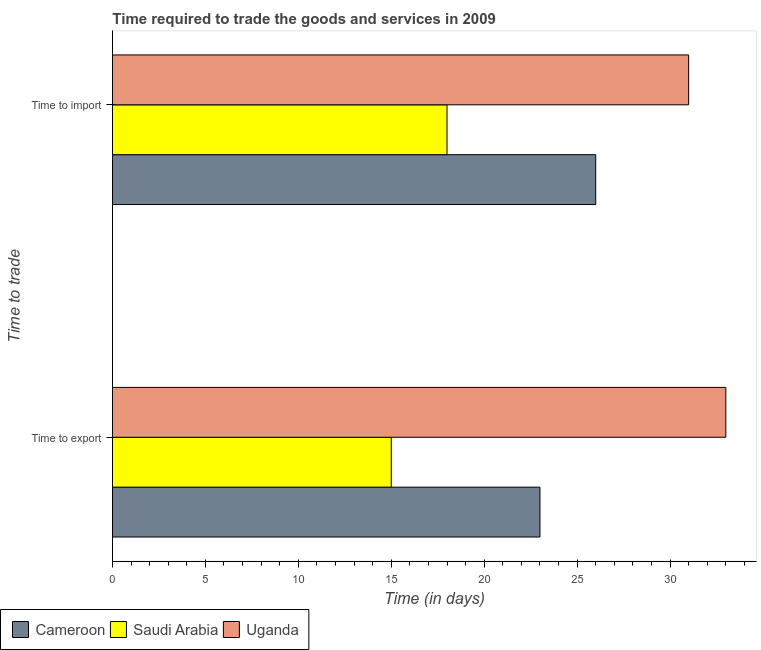Are the number of bars per tick equal to the number of legend labels?
Offer a very short reply. Yes. How many bars are there on the 1st tick from the bottom?
Keep it short and to the point. 3. What is the label of the 1st group of bars from the top?
Offer a terse response. Time to import. What is the time to import in Cameroon?
Offer a very short reply. 26. Across all countries, what is the maximum time to export?
Provide a short and direct response. 33. Across all countries, what is the minimum time to import?
Offer a very short reply. 18. In which country was the time to export maximum?
Provide a short and direct response. Uganda. In which country was the time to export minimum?
Your answer should be compact. Saudi Arabia. What is the total time to import in the graph?
Your response must be concise. 75. What is the difference between the time to export in Saudi Arabia and that in Uganda?
Ensure brevity in your answer.  -18. What is the difference between the time to import in Cameroon and the time to export in Saudi Arabia?
Your answer should be very brief. 11. What is the difference between the time to import and time to export in Uganda?
Ensure brevity in your answer.  -2. In how many countries, is the time to export greater than 20 days?
Ensure brevity in your answer.  2. What is the ratio of the time to import in Saudi Arabia to that in Cameroon?
Your response must be concise. 0.69. Is the time to export in Saudi Arabia less than that in Uganda?
Your response must be concise. Yes. What does the 2nd bar from the top in Time to export represents?
Make the answer very short. Saudi Arabia. What does the 1st bar from the bottom in Time to export represents?
Provide a short and direct response. Cameroon. How many bars are there?
Provide a short and direct response. 6. Are the values on the major ticks of X-axis written in scientific E-notation?
Your answer should be very brief. No. Does the graph contain any zero values?
Provide a short and direct response. No. Does the graph contain grids?
Your answer should be very brief. No. How many legend labels are there?
Your answer should be very brief. 3. How are the legend labels stacked?
Make the answer very short. Horizontal. What is the title of the graph?
Offer a very short reply. Time required to trade the goods and services in 2009. What is the label or title of the X-axis?
Your answer should be compact. Time (in days). What is the label or title of the Y-axis?
Your answer should be very brief. Time to trade. What is the Time (in days) in Cameroon in Time to export?
Your answer should be compact. 23. What is the Time (in days) in Saudi Arabia in Time to export?
Keep it short and to the point. 15. What is the Time (in days) of Uganda in Time to export?
Provide a succinct answer. 33. What is the Time (in days) in Saudi Arabia in Time to import?
Offer a terse response. 18. What is the Time (in days) of Uganda in Time to import?
Give a very brief answer. 31. Across all Time to trade, what is the maximum Time (in days) of Uganda?
Your answer should be very brief. 33. Across all Time to trade, what is the minimum Time (in days) of Uganda?
Keep it short and to the point. 31. What is the total Time (in days) in Uganda in the graph?
Give a very brief answer. 64. What is the difference between the Time (in days) of Cameroon in Time to export and that in Time to import?
Offer a terse response. -3. What is the difference between the Time (in days) in Saudi Arabia in Time to export and that in Time to import?
Your response must be concise. -3. What is the difference between the Time (in days) of Uganda in Time to export and that in Time to import?
Provide a short and direct response. 2. What is the difference between the Time (in days) in Cameroon in Time to export and the Time (in days) in Saudi Arabia in Time to import?
Offer a very short reply. 5. What is the average Time (in days) in Cameroon per Time to trade?
Make the answer very short. 24.5. What is the difference between the Time (in days) of Cameroon and Time (in days) of Uganda in Time to export?
Your answer should be very brief. -10. What is the difference between the Time (in days) of Saudi Arabia and Time (in days) of Uganda in Time to export?
Make the answer very short. -18. What is the difference between the Time (in days) of Cameroon and Time (in days) of Uganda in Time to import?
Your response must be concise. -5. What is the difference between the Time (in days) in Saudi Arabia and Time (in days) in Uganda in Time to import?
Keep it short and to the point. -13. What is the ratio of the Time (in days) of Cameroon in Time to export to that in Time to import?
Keep it short and to the point. 0.88. What is the ratio of the Time (in days) in Saudi Arabia in Time to export to that in Time to import?
Ensure brevity in your answer.  0.83. What is the ratio of the Time (in days) in Uganda in Time to export to that in Time to import?
Keep it short and to the point. 1.06. What is the difference between the highest and the lowest Time (in days) in Cameroon?
Provide a succinct answer. 3. What is the difference between the highest and the lowest Time (in days) of Saudi Arabia?
Your response must be concise. 3. 